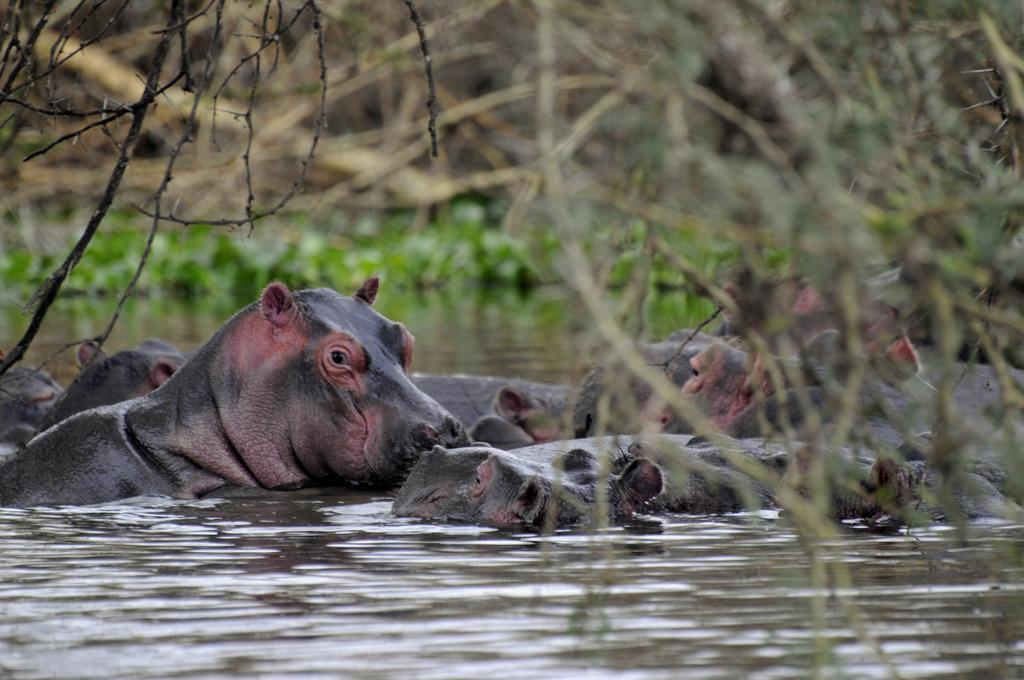What type of animals can be seen in the image? Animals in the water can be seen in the image. What else is visible in the image besides the animals? Plants are visible in the image. What is the shocking distance from the edge of the water in the image? There is no mention of a shock or distance from the edge in the image, as it only features animals in the water and plants. 